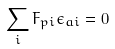<formula> <loc_0><loc_0><loc_500><loc_500>\sum _ { i } F _ { p i } \epsilon _ { a i } = 0</formula> 